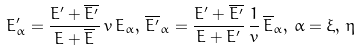<formula> <loc_0><loc_0><loc_500><loc_500>E ^ { \prime } _ { \alpha } = \frac { E ^ { \prime } + \overline { E ^ { \prime } } } { E + \overline { E } } \, v \, E _ { \alpha } , \, \overline { E ^ { \prime } } _ { \alpha } = \frac { E ^ { \prime } + \overline { E ^ { \prime } } } { E + E ^ { \prime } } \, \frac { 1 } { v } \, \overline { E } _ { \alpha } , \, \alpha = \xi , \, \eta</formula> 